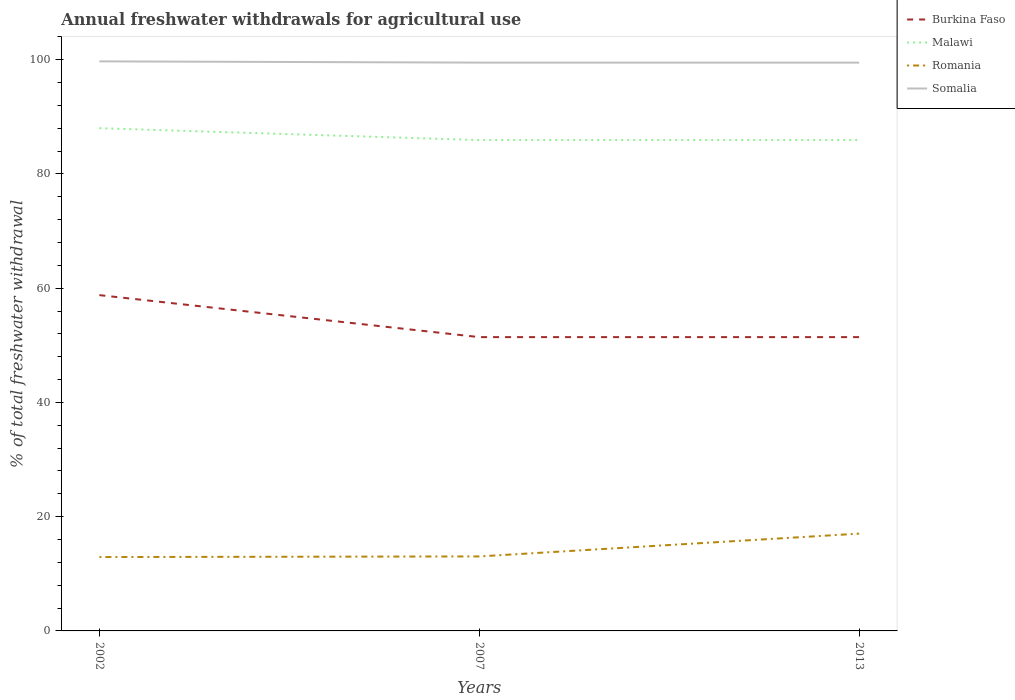How many different coloured lines are there?
Give a very brief answer. 4. Does the line corresponding to Burkina Faso intersect with the line corresponding to Malawi?
Your response must be concise. No. Is the number of lines equal to the number of legend labels?
Your answer should be very brief. Yes. Across all years, what is the maximum total annual withdrawals from freshwater in Malawi?
Provide a short and direct response. 85.92. What is the total total annual withdrawals from freshwater in Burkina Faso in the graph?
Keep it short and to the point. 7.35. What is the difference between the highest and the second highest total annual withdrawals from freshwater in Somalia?
Your answer should be compact. 0.22. Is the total annual withdrawals from freshwater in Somalia strictly greater than the total annual withdrawals from freshwater in Burkina Faso over the years?
Keep it short and to the point. No. How many lines are there?
Offer a terse response. 4. Are the values on the major ticks of Y-axis written in scientific E-notation?
Your answer should be compact. No. Where does the legend appear in the graph?
Keep it short and to the point. Top right. What is the title of the graph?
Your response must be concise. Annual freshwater withdrawals for agricultural use. What is the label or title of the X-axis?
Provide a succinct answer. Years. What is the label or title of the Y-axis?
Keep it short and to the point. % of total freshwater withdrawal. What is the % of total freshwater withdrawal in Burkina Faso in 2002?
Give a very brief answer. 58.78. What is the % of total freshwater withdrawal in Malawi in 2002?
Keep it short and to the point. 88. What is the % of total freshwater withdrawal of Romania in 2002?
Your answer should be compact. 12.93. What is the % of total freshwater withdrawal in Somalia in 2002?
Provide a succinct answer. 99.7. What is the % of total freshwater withdrawal of Burkina Faso in 2007?
Give a very brief answer. 51.43. What is the % of total freshwater withdrawal of Malawi in 2007?
Provide a succinct answer. 85.92. What is the % of total freshwater withdrawal in Romania in 2007?
Provide a succinct answer. 13.04. What is the % of total freshwater withdrawal in Somalia in 2007?
Your answer should be compact. 99.48. What is the % of total freshwater withdrawal in Burkina Faso in 2013?
Give a very brief answer. 51.43. What is the % of total freshwater withdrawal of Malawi in 2013?
Your answer should be compact. 85.92. What is the % of total freshwater withdrawal in Romania in 2013?
Offer a terse response. 17.03. What is the % of total freshwater withdrawal in Somalia in 2013?
Provide a short and direct response. 99.48. Across all years, what is the maximum % of total freshwater withdrawal in Burkina Faso?
Offer a very short reply. 58.78. Across all years, what is the maximum % of total freshwater withdrawal of Romania?
Your answer should be compact. 17.03. Across all years, what is the maximum % of total freshwater withdrawal in Somalia?
Your answer should be very brief. 99.7. Across all years, what is the minimum % of total freshwater withdrawal in Burkina Faso?
Offer a terse response. 51.43. Across all years, what is the minimum % of total freshwater withdrawal in Malawi?
Give a very brief answer. 85.92. Across all years, what is the minimum % of total freshwater withdrawal in Romania?
Your answer should be very brief. 12.93. Across all years, what is the minimum % of total freshwater withdrawal of Somalia?
Make the answer very short. 99.48. What is the total % of total freshwater withdrawal of Burkina Faso in the graph?
Your answer should be very brief. 161.64. What is the total % of total freshwater withdrawal in Malawi in the graph?
Provide a short and direct response. 259.84. What is the total % of total freshwater withdrawal in Romania in the graph?
Your answer should be very brief. 43. What is the total % of total freshwater withdrawal of Somalia in the graph?
Keep it short and to the point. 298.66. What is the difference between the % of total freshwater withdrawal of Burkina Faso in 2002 and that in 2007?
Give a very brief answer. 7.35. What is the difference between the % of total freshwater withdrawal in Malawi in 2002 and that in 2007?
Your answer should be compact. 2.08. What is the difference between the % of total freshwater withdrawal in Romania in 2002 and that in 2007?
Keep it short and to the point. -0.11. What is the difference between the % of total freshwater withdrawal of Somalia in 2002 and that in 2007?
Make the answer very short. 0.22. What is the difference between the % of total freshwater withdrawal in Burkina Faso in 2002 and that in 2013?
Provide a succinct answer. 7.35. What is the difference between the % of total freshwater withdrawal of Malawi in 2002 and that in 2013?
Provide a succinct answer. 2.08. What is the difference between the % of total freshwater withdrawal in Somalia in 2002 and that in 2013?
Provide a succinct answer. 0.22. What is the difference between the % of total freshwater withdrawal in Romania in 2007 and that in 2013?
Make the answer very short. -3.99. What is the difference between the % of total freshwater withdrawal in Somalia in 2007 and that in 2013?
Ensure brevity in your answer.  0. What is the difference between the % of total freshwater withdrawal of Burkina Faso in 2002 and the % of total freshwater withdrawal of Malawi in 2007?
Your response must be concise. -27.14. What is the difference between the % of total freshwater withdrawal in Burkina Faso in 2002 and the % of total freshwater withdrawal in Romania in 2007?
Offer a terse response. 45.74. What is the difference between the % of total freshwater withdrawal of Burkina Faso in 2002 and the % of total freshwater withdrawal of Somalia in 2007?
Offer a terse response. -40.7. What is the difference between the % of total freshwater withdrawal of Malawi in 2002 and the % of total freshwater withdrawal of Romania in 2007?
Offer a very short reply. 74.96. What is the difference between the % of total freshwater withdrawal of Malawi in 2002 and the % of total freshwater withdrawal of Somalia in 2007?
Keep it short and to the point. -11.48. What is the difference between the % of total freshwater withdrawal of Romania in 2002 and the % of total freshwater withdrawal of Somalia in 2007?
Your response must be concise. -86.55. What is the difference between the % of total freshwater withdrawal of Burkina Faso in 2002 and the % of total freshwater withdrawal of Malawi in 2013?
Offer a terse response. -27.14. What is the difference between the % of total freshwater withdrawal in Burkina Faso in 2002 and the % of total freshwater withdrawal in Romania in 2013?
Make the answer very short. 41.75. What is the difference between the % of total freshwater withdrawal of Burkina Faso in 2002 and the % of total freshwater withdrawal of Somalia in 2013?
Offer a very short reply. -40.7. What is the difference between the % of total freshwater withdrawal of Malawi in 2002 and the % of total freshwater withdrawal of Romania in 2013?
Your response must be concise. 70.97. What is the difference between the % of total freshwater withdrawal of Malawi in 2002 and the % of total freshwater withdrawal of Somalia in 2013?
Your answer should be compact. -11.48. What is the difference between the % of total freshwater withdrawal in Romania in 2002 and the % of total freshwater withdrawal in Somalia in 2013?
Your response must be concise. -86.55. What is the difference between the % of total freshwater withdrawal in Burkina Faso in 2007 and the % of total freshwater withdrawal in Malawi in 2013?
Make the answer very short. -34.49. What is the difference between the % of total freshwater withdrawal in Burkina Faso in 2007 and the % of total freshwater withdrawal in Romania in 2013?
Make the answer very short. 34.4. What is the difference between the % of total freshwater withdrawal of Burkina Faso in 2007 and the % of total freshwater withdrawal of Somalia in 2013?
Give a very brief answer. -48.05. What is the difference between the % of total freshwater withdrawal in Malawi in 2007 and the % of total freshwater withdrawal in Romania in 2013?
Give a very brief answer. 68.89. What is the difference between the % of total freshwater withdrawal of Malawi in 2007 and the % of total freshwater withdrawal of Somalia in 2013?
Your answer should be very brief. -13.56. What is the difference between the % of total freshwater withdrawal of Romania in 2007 and the % of total freshwater withdrawal of Somalia in 2013?
Offer a very short reply. -86.44. What is the average % of total freshwater withdrawal of Burkina Faso per year?
Make the answer very short. 53.88. What is the average % of total freshwater withdrawal in Malawi per year?
Keep it short and to the point. 86.61. What is the average % of total freshwater withdrawal in Romania per year?
Keep it short and to the point. 14.33. What is the average % of total freshwater withdrawal in Somalia per year?
Offer a very short reply. 99.55. In the year 2002, what is the difference between the % of total freshwater withdrawal in Burkina Faso and % of total freshwater withdrawal in Malawi?
Keep it short and to the point. -29.22. In the year 2002, what is the difference between the % of total freshwater withdrawal in Burkina Faso and % of total freshwater withdrawal in Romania?
Your answer should be very brief. 45.85. In the year 2002, what is the difference between the % of total freshwater withdrawal of Burkina Faso and % of total freshwater withdrawal of Somalia?
Your answer should be compact. -40.92. In the year 2002, what is the difference between the % of total freshwater withdrawal in Malawi and % of total freshwater withdrawal in Romania?
Your response must be concise. 75.07. In the year 2002, what is the difference between the % of total freshwater withdrawal of Malawi and % of total freshwater withdrawal of Somalia?
Offer a very short reply. -11.7. In the year 2002, what is the difference between the % of total freshwater withdrawal in Romania and % of total freshwater withdrawal in Somalia?
Ensure brevity in your answer.  -86.77. In the year 2007, what is the difference between the % of total freshwater withdrawal of Burkina Faso and % of total freshwater withdrawal of Malawi?
Keep it short and to the point. -34.49. In the year 2007, what is the difference between the % of total freshwater withdrawal of Burkina Faso and % of total freshwater withdrawal of Romania?
Give a very brief answer. 38.39. In the year 2007, what is the difference between the % of total freshwater withdrawal of Burkina Faso and % of total freshwater withdrawal of Somalia?
Keep it short and to the point. -48.05. In the year 2007, what is the difference between the % of total freshwater withdrawal of Malawi and % of total freshwater withdrawal of Romania?
Keep it short and to the point. 72.88. In the year 2007, what is the difference between the % of total freshwater withdrawal of Malawi and % of total freshwater withdrawal of Somalia?
Offer a terse response. -13.56. In the year 2007, what is the difference between the % of total freshwater withdrawal in Romania and % of total freshwater withdrawal in Somalia?
Ensure brevity in your answer.  -86.44. In the year 2013, what is the difference between the % of total freshwater withdrawal of Burkina Faso and % of total freshwater withdrawal of Malawi?
Give a very brief answer. -34.49. In the year 2013, what is the difference between the % of total freshwater withdrawal in Burkina Faso and % of total freshwater withdrawal in Romania?
Your response must be concise. 34.4. In the year 2013, what is the difference between the % of total freshwater withdrawal of Burkina Faso and % of total freshwater withdrawal of Somalia?
Keep it short and to the point. -48.05. In the year 2013, what is the difference between the % of total freshwater withdrawal in Malawi and % of total freshwater withdrawal in Romania?
Your response must be concise. 68.89. In the year 2013, what is the difference between the % of total freshwater withdrawal in Malawi and % of total freshwater withdrawal in Somalia?
Your answer should be compact. -13.56. In the year 2013, what is the difference between the % of total freshwater withdrawal of Romania and % of total freshwater withdrawal of Somalia?
Your response must be concise. -82.45. What is the ratio of the % of total freshwater withdrawal of Burkina Faso in 2002 to that in 2007?
Your answer should be very brief. 1.14. What is the ratio of the % of total freshwater withdrawal of Malawi in 2002 to that in 2007?
Offer a very short reply. 1.02. What is the ratio of the % of total freshwater withdrawal in Somalia in 2002 to that in 2007?
Offer a very short reply. 1. What is the ratio of the % of total freshwater withdrawal in Burkina Faso in 2002 to that in 2013?
Give a very brief answer. 1.14. What is the ratio of the % of total freshwater withdrawal of Malawi in 2002 to that in 2013?
Offer a very short reply. 1.02. What is the ratio of the % of total freshwater withdrawal in Romania in 2002 to that in 2013?
Offer a terse response. 0.76. What is the ratio of the % of total freshwater withdrawal of Somalia in 2002 to that in 2013?
Your answer should be very brief. 1. What is the ratio of the % of total freshwater withdrawal in Burkina Faso in 2007 to that in 2013?
Ensure brevity in your answer.  1. What is the ratio of the % of total freshwater withdrawal of Romania in 2007 to that in 2013?
Provide a short and direct response. 0.77. What is the ratio of the % of total freshwater withdrawal in Somalia in 2007 to that in 2013?
Provide a short and direct response. 1. What is the difference between the highest and the second highest % of total freshwater withdrawal of Burkina Faso?
Give a very brief answer. 7.35. What is the difference between the highest and the second highest % of total freshwater withdrawal in Malawi?
Your answer should be compact. 2.08. What is the difference between the highest and the second highest % of total freshwater withdrawal of Romania?
Provide a succinct answer. 3.99. What is the difference between the highest and the second highest % of total freshwater withdrawal in Somalia?
Offer a terse response. 0.22. What is the difference between the highest and the lowest % of total freshwater withdrawal in Burkina Faso?
Offer a terse response. 7.35. What is the difference between the highest and the lowest % of total freshwater withdrawal in Malawi?
Your answer should be compact. 2.08. What is the difference between the highest and the lowest % of total freshwater withdrawal in Romania?
Your answer should be very brief. 4.1. What is the difference between the highest and the lowest % of total freshwater withdrawal of Somalia?
Your answer should be compact. 0.22. 